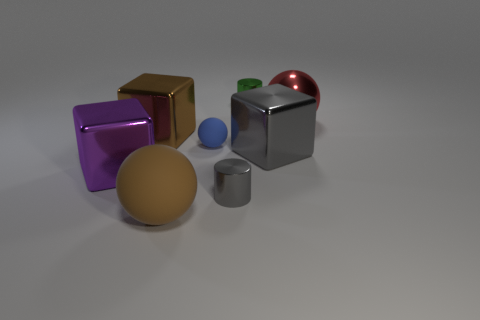The other object that is the same color as the large matte thing is what size?
Your response must be concise. Large. Are the cylinder that is in front of the red ball and the ball that is behind the blue object made of the same material?
Your answer should be very brief. Yes. Is the number of big purple objects greater than the number of shiny cylinders?
Your answer should be very brief. No. Are there any other things that are the same color as the metal ball?
Make the answer very short. No. Does the large purple object have the same material as the small green cylinder?
Your answer should be very brief. Yes. Are there fewer large purple shiny things than large cyan matte balls?
Give a very brief answer. No. Is the tiny green thing the same shape as the small gray metal object?
Provide a short and direct response. Yes. What is the color of the big matte sphere?
Keep it short and to the point. Brown. What number of other objects are the same material as the large purple cube?
Your answer should be compact. 5. What number of yellow things are either large metal spheres or rubber objects?
Give a very brief answer. 0. 